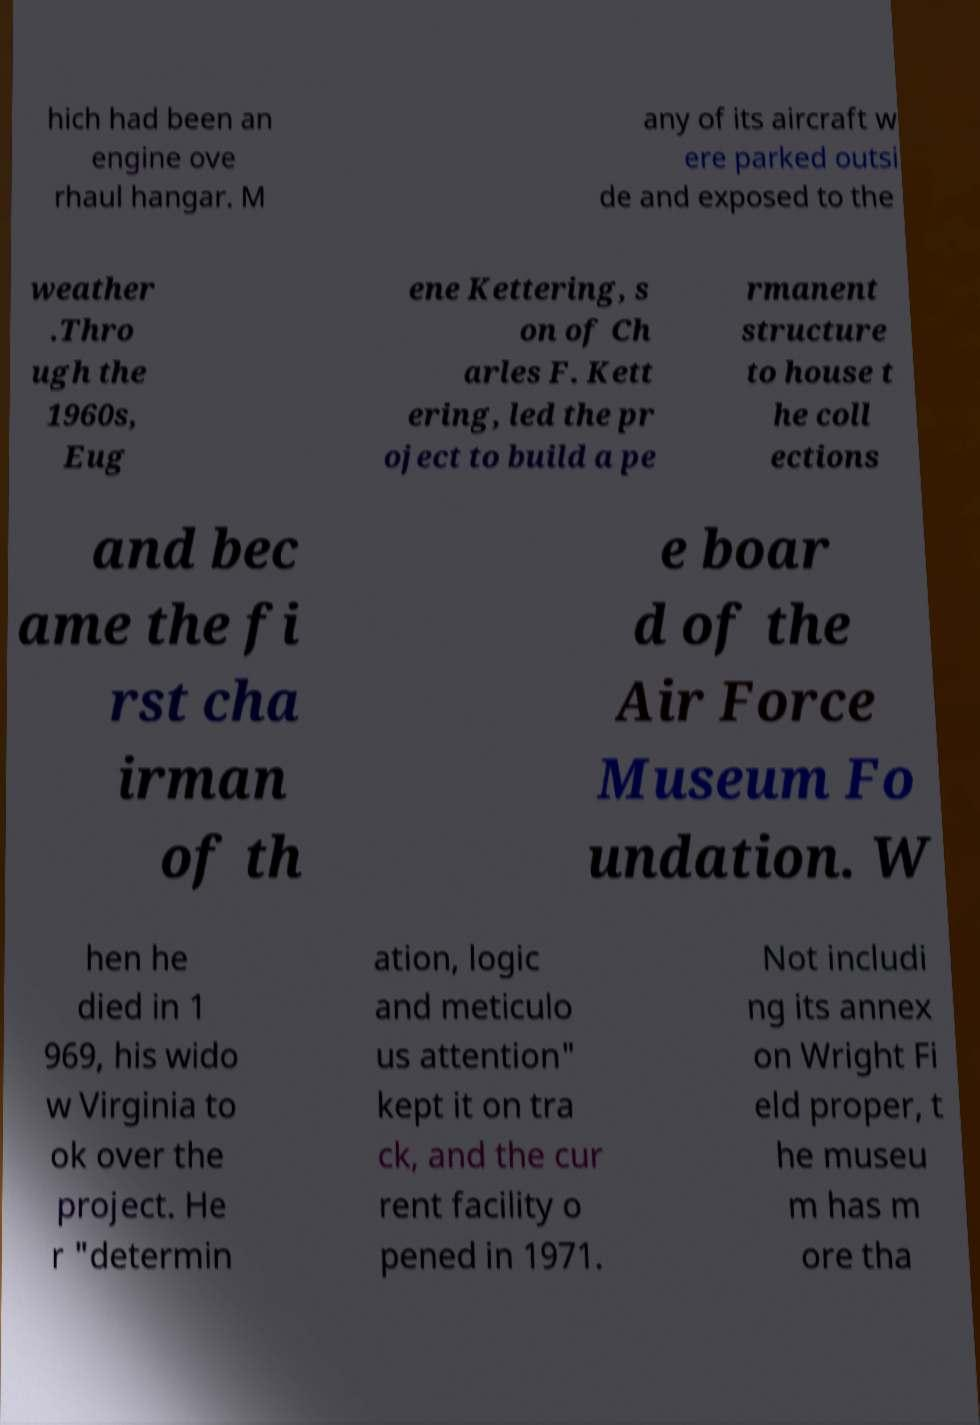Can you accurately transcribe the text from the provided image for me? hich had been an engine ove rhaul hangar. M any of its aircraft w ere parked outsi de and exposed to the weather .Thro ugh the 1960s, Eug ene Kettering, s on of Ch arles F. Kett ering, led the pr oject to build a pe rmanent structure to house t he coll ections and bec ame the fi rst cha irman of th e boar d of the Air Force Museum Fo undation. W hen he died in 1 969, his wido w Virginia to ok over the project. He r "determin ation, logic and meticulo us attention" kept it on tra ck, and the cur rent facility o pened in 1971. Not includi ng its annex on Wright Fi eld proper, t he museu m has m ore tha 